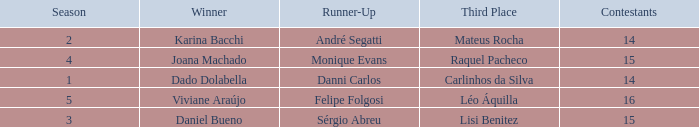In what season did Raquel Pacheco finish in third place? 4.0. Parse the full table. {'header': ['Season', 'Winner', 'Runner-Up', 'Third Place', 'Contestants'], 'rows': [['2', 'Karina Bacchi', 'André Segatti', 'Mateus Rocha', '14'], ['4', 'Joana Machado', 'Monique Evans', 'Raquel Pacheco', '15'], ['1', 'Dado Dolabella', 'Danni Carlos', 'Carlinhos da Silva', '14'], ['5', 'Viviane Araújo', 'Felipe Folgosi', 'Léo Áquilla', '16'], ['3', 'Daniel Bueno', 'Sérgio Abreu', 'Lisi Benitez', '15']]} 